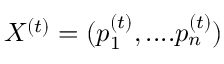Convert formula to latex. <formula><loc_0><loc_0><loc_500><loc_500>X ^ { ( t ) } = ( p _ { 1 } ^ { ( t ) } , \cdots p _ { n } ^ { ( t ) } )</formula> 